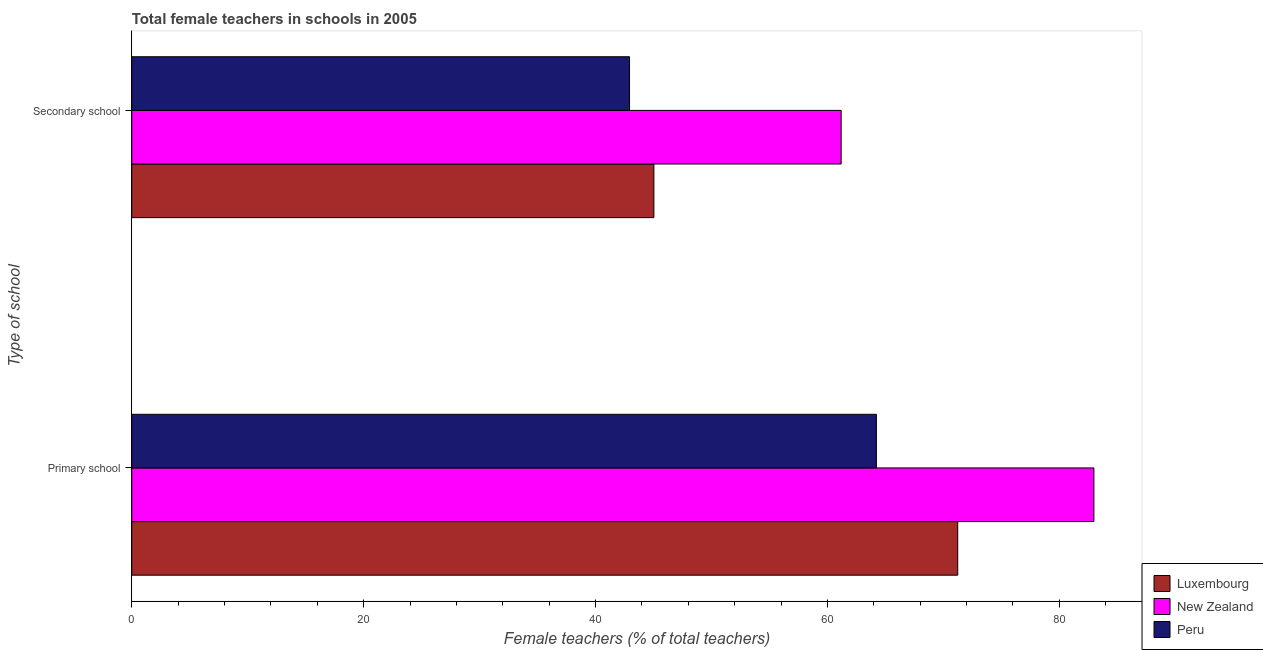How many different coloured bars are there?
Provide a succinct answer. 3. How many groups of bars are there?
Provide a succinct answer. 2. Are the number of bars per tick equal to the number of legend labels?
Ensure brevity in your answer.  Yes. How many bars are there on the 2nd tick from the bottom?
Your response must be concise. 3. What is the label of the 1st group of bars from the top?
Provide a short and direct response. Secondary school. What is the percentage of female teachers in secondary schools in New Zealand?
Give a very brief answer. 61.18. Across all countries, what is the maximum percentage of female teachers in secondary schools?
Your answer should be very brief. 61.18. Across all countries, what is the minimum percentage of female teachers in primary schools?
Your answer should be compact. 64.23. In which country was the percentage of female teachers in secondary schools maximum?
Give a very brief answer. New Zealand. In which country was the percentage of female teachers in secondary schools minimum?
Offer a terse response. Peru. What is the total percentage of female teachers in secondary schools in the graph?
Give a very brief answer. 149.15. What is the difference between the percentage of female teachers in secondary schools in New Zealand and that in Peru?
Ensure brevity in your answer.  18.25. What is the difference between the percentage of female teachers in secondary schools in Peru and the percentage of female teachers in primary schools in New Zealand?
Ensure brevity in your answer.  -40.05. What is the average percentage of female teachers in secondary schools per country?
Your answer should be compact. 49.72. What is the difference between the percentage of female teachers in secondary schools and percentage of female teachers in primary schools in Peru?
Make the answer very short. -21.29. What is the ratio of the percentage of female teachers in primary schools in Luxembourg to that in New Zealand?
Provide a succinct answer. 0.86. Is the percentage of female teachers in secondary schools in Luxembourg less than that in New Zealand?
Provide a short and direct response. Yes. What does the 1st bar from the top in Secondary school represents?
Provide a short and direct response. Peru. What does the 1st bar from the bottom in Secondary school represents?
Keep it short and to the point. Luxembourg. Are all the bars in the graph horizontal?
Offer a terse response. Yes. What is the difference between two consecutive major ticks on the X-axis?
Your response must be concise. 20. Does the graph contain any zero values?
Your response must be concise. No. Where does the legend appear in the graph?
Your response must be concise. Bottom right. How are the legend labels stacked?
Ensure brevity in your answer.  Vertical. What is the title of the graph?
Provide a succinct answer. Total female teachers in schools in 2005. What is the label or title of the X-axis?
Provide a succinct answer. Female teachers (% of total teachers). What is the label or title of the Y-axis?
Give a very brief answer. Type of school. What is the Female teachers (% of total teachers) in Luxembourg in Primary school?
Offer a very short reply. 71.24. What is the Female teachers (% of total teachers) of New Zealand in Primary school?
Make the answer very short. 82.99. What is the Female teachers (% of total teachers) in Peru in Primary school?
Ensure brevity in your answer.  64.23. What is the Female teachers (% of total teachers) in Luxembourg in Secondary school?
Offer a very short reply. 45.03. What is the Female teachers (% of total teachers) in New Zealand in Secondary school?
Offer a very short reply. 61.18. What is the Female teachers (% of total teachers) of Peru in Secondary school?
Provide a succinct answer. 42.93. Across all Type of school, what is the maximum Female teachers (% of total teachers) in Luxembourg?
Your response must be concise. 71.24. Across all Type of school, what is the maximum Female teachers (% of total teachers) of New Zealand?
Provide a succinct answer. 82.99. Across all Type of school, what is the maximum Female teachers (% of total teachers) in Peru?
Ensure brevity in your answer.  64.23. Across all Type of school, what is the minimum Female teachers (% of total teachers) of Luxembourg?
Make the answer very short. 45.03. Across all Type of school, what is the minimum Female teachers (% of total teachers) in New Zealand?
Give a very brief answer. 61.18. Across all Type of school, what is the minimum Female teachers (% of total teachers) of Peru?
Offer a terse response. 42.93. What is the total Female teachers (% of total teachers) in Luxembourg in the graph?
Provide a short and direct response. 116.27. What is the total Female teachers (% of total teachers) in New Zealand in the graph?
Make the answer very short. 144.17. What is the total Female teachers (% of total teachers) in Peru in the graph?
Provide a short and direct response. 107.16. What is the difference between the Female teachers (% of total teachers) of Luxembourg in Primary school and that in Secondary school?
Your response must be concise. 26.21. What is the difference between the Female teachers (% of total teachers) of New Zealand in Primary school and that in Secondary school?
Offer a very short reply. 21.8. What is the difference between the Female teachers (% of total teachers) of Peru in Primary school and that in Secondary school?
Provide a short and direct response. 21.29. What is the difference between the Female teachers (% of total teachers) in Luxembourg in Primary school and the Female teachers (% of total teachers) in New Zealand in Secondary school?
Keep it short and to the point. 10.06. What is the difference between the Female teachers (% of total teachers) of Luxembourg in Primary school and the Female teachers (% of total teachers) of Peru in Secondary school?
Provide a short and direct response. 28.31. What is the difference between the Female teachers (% of total teachers) in New Zealand in Primary school and the Female teachers (% of total teachers) in Peru in Secondary school?
Your response must be concise. 40.05. What is the average Female teachers (% of total teachers) of Luxembourg per Type of school?
Your response must be concise. 58.14. What is the average Female teachers (% of total teachers) of New Zealand per Type of school?
Your response must be concise. 72.08. What is the average Female teachers (% of total teachers) in Peru per Type of school?
Your response must be concise. 53.58. What is the difference between the Female teachers (% of total teachers) in Luxembourg and Female teachers (% of total teachers) in New Zealand in Primary school?
Offer a very short reply. -11.75. What is the difference between the Female teachers (% of total teachers) in Luxembourg and Female teachers (% of total teachers) in Peru in Primary school?
Provide a succinct answer. 7.01. What is the difference between the Female teachers (% of total teachers) of New Zealand and Female teachers (% of total teachers) of Peru in Primary school?
Ensure brevity in your answer.  18.76. What is the difference between the Female teachers (% of total teachers) of Luxembourg and Female teachers (% of total teachers) of New Zealand in Secondary school?
Give a very brief answer. -16.15. What is the difference between the Female teachers (% of total teachers) in Luxembourg and Female teachers (% of total teachers) in Peru in Secondary school?
Give a very brief answer. 2.1. What is the difference between the Female teachers (% of total teachers) of New Zealand and Female teachers (% of total teachers) of Peru in Secondary school?
Your response must be concise. 18.25. What is the ratio of the Female teachers (% of total teachers) of Luxembourg in Primary school to that in Secondary school?
Give a very brief answer. 1.58. What is the ratio of the Female teachers (% of total teachers) in New Zealand in Primary school to that in Secondary school?
Your answer should be very brief. 1.36. What is the ratio of the Female teachers (% of total teachers) of Peru in Primary school to that in Secondary school?
Ensure brevity in your answer.  1.5. What is the difference between the highest and the second highest Female teachers (% of total teachers) in Luxembourg?
Your answer should be very brief. 26.21. What is the difference between the highest and the second highest Female teachers (% of total teachers) of New Zealand?
Provide a succinct answer. 21.8. What is the difference between the highest and the second highest Female teachers (% of total teachers) of Peru?
Make the answer very short. 21.29. What is the difference between the highest and the lowest Female teachers (% of total teachers) in Luxembourg?
Keep it short and to the point. 26.21. What is the difference between the highest and the lowest Female teachers (% of total teachers) in New Zealand?
Offer a terse response. 21.8. What is the difference between the highest and the lowest Female teachers (% of total teachers) in Peru?
Make the answer very short. 21.29. 